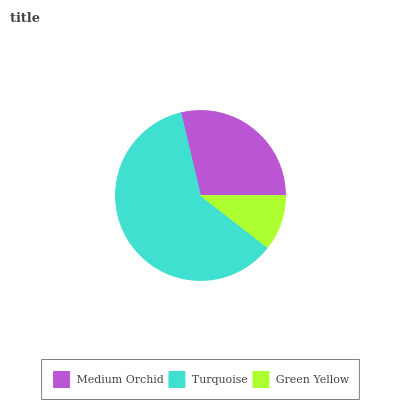Is Green Yellow the minimum?
Answer yes or no. Yes. Is Turquoise the maximum?
Answer yes or no. Yes. Is Turquoise the minimum?
Answer yes or no. No. Is Green Yellow the maximum?
Answer yes or no. No. Is Turquoise greater than Green Yellow?
Answer yes or no. Yes. Is Green Yellow less than Turquoise?
Answer yes or no. Yes. Is Green Yellow greater than Turquoise?
Answer yes or no. No. Is Turquoise less than Green Yellow?
Answer yes or no. No. Is Medium Orchid the high median?
Answer yes or no. Yes. Is Medium Orchid the low median?
Answer yes or no. Yes. Is Green Yellow the high median?
Answer yes or no. No. Is Turquoise the low median?
Answer yes or no. No. 